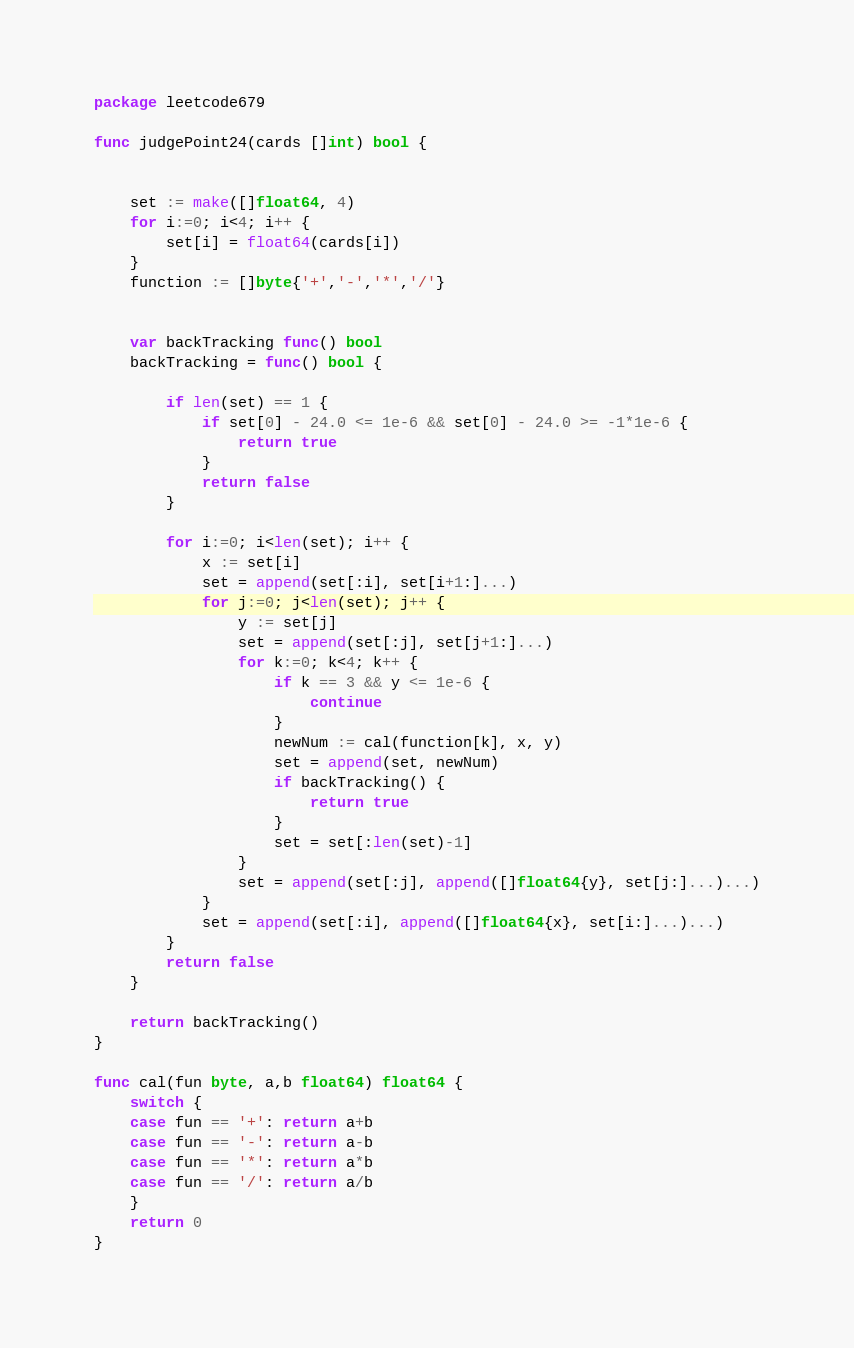Convert code to text. <code><loc_0><loc_0><loc_500><loc_500><_Go_>package leetcode679

func judgePoint24(cards []int) bool {


	set := make([]float64, 4)
	for i:=0; i<4; i++ {
		set[i] = float64(cards[i])
	}
	function := []byte{'+','-','*','/'}


	var backTracking func() bool
	backTracking = func() bool {

		if len(set) == 1 {
			if set[0] - 24.0 <= 1e-6 && set[0] - 24.0 >= -1*1e-6 {
				return true
			}
			return false
		}

		for i:=0; i<len(set); i++ {
			x := set[i]
			set = append(set[:i], set[i+1:]...)
			for j:=0; j<len(set); j++ {
				y := set[j]
				set = append(set[:j], set[j+1:]...)
				for k:=0; k<4; k++ {
					if k == 3 && y <= 1e-6 {
						continue
					}
					newNum := cal(function[k], x, y)
					set = append(set, newNum)
					if backTracking() {
						return true
					}
					set = set[:len(set)-1]
				}
				set = append(set[:j], append([]float64{y}, set[j:]...)...)
			}
			set = append(set[:i], append([]float64{x}, set[i:]...)...)
		}
		return false
	}

	return backTracking()
}

func cal(fun byte, a,b float64) float64 {
	switch {
	case fun == '+': return a+b
	case fun == '-': return a-b
	case fun == '*': return a*b
	case fun == '/': return a/b 
	}
	return 0
}</code> 